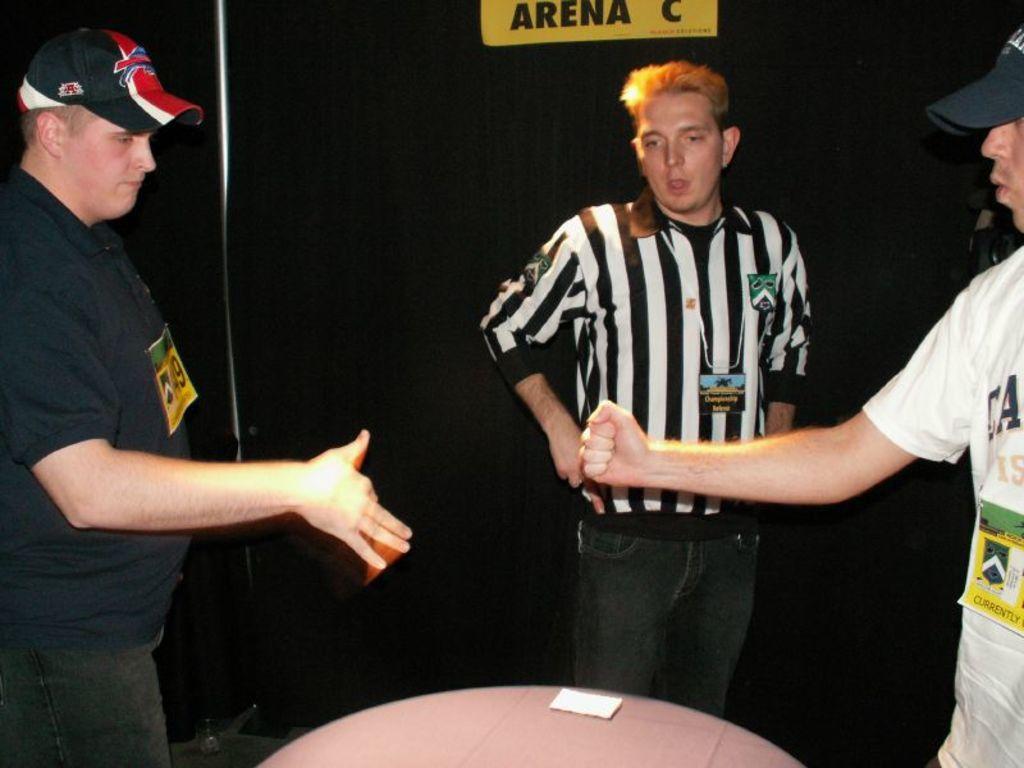Where are they?
Offer a terse response. Arena c. 